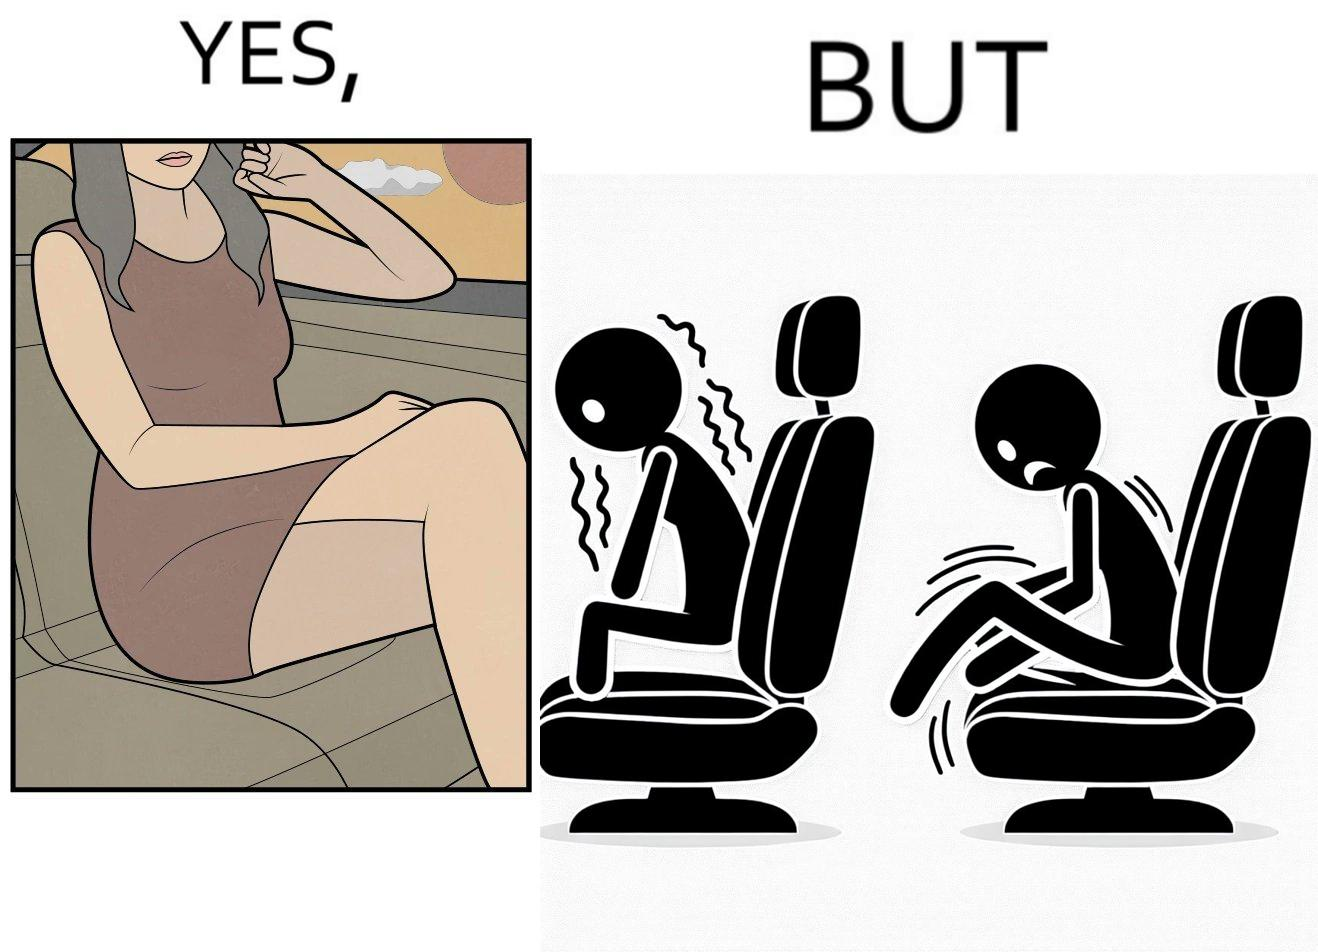Describe what you see in the left and right parts of this image. In the left part of the image: a woman wearing a short dress sitting on the co-passengers seat in a car In the right part of the image: skin of a woman getting sticked to the seat fabric of the car, causing inconvenience 